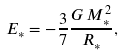Convert formula to latex. <formula><loc_0><loc_0><loc_500><loc_500>E _ { \ast } = - \frac { 3 } { 7 } \frac { G \, M _ { \ast } ^ { 2 } } { R _ { \ast } } ,</formula> 